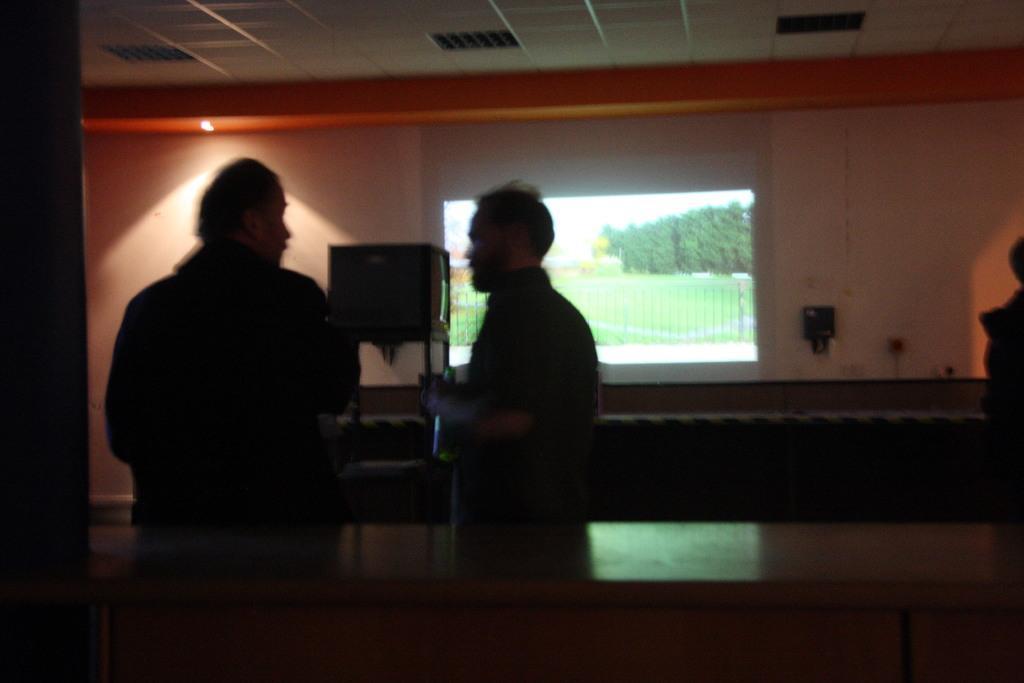How would you summarize this image in a sentence or two? In this picture there are two persons standing beside the table. Both of them are wearing black shirts and one of the person is holding a bottle. In the center, there is a screen. On the screen there are plants, grass can be seen. On the top there is a ceiling. 